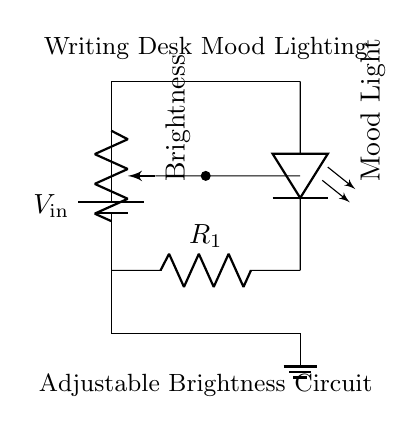What component is used to adjust brightness? The circuit includes a potentiometer labeled "Brightness," which is typically used to vary the resistance and control the brightness of the LED by adjusting the current flowing through it.
Answer: Potentiometer What is the role of resistor R1? Resistor R1 is a current limiting resistor, which helps to prevent excessive current from flowing through the LED, protecting it from damage and ensuring it operates within its specified parameters.
Answer: Current limiting What type of light does this circuit produce? The circuit features a light-emitting diode (LED) labeled "Mood Light," which provides illumination for creating ambiance and setting a mood in the writing area.
Answer: Mood light How many key components are in the circuit? The circuit consists of four key components: the battery, potentiometer, LED, and current limiting resistor, which combine to provide adjustable mood lighting.
Answer: Four What is the input voltage represented in the circuit? The input voltage is denoted as V in, indicating the source of electrical energy that powers the circuit, though the exact voltage value is not specified in the diagram.
Answer: V in Which component connects to ground? The ground connection is made at the bottom of the circuit diagram, which shows that current returns to the reference point of the circuit after passing through the other components.
Answer: Ground What might happen if R1 has a very low resistance? If R1 has a very low resistance, it could allow too much current to flow through the LED, possibly leading to overcurrent conditions that could burn out the LED.
Answer: Burn out the LED 